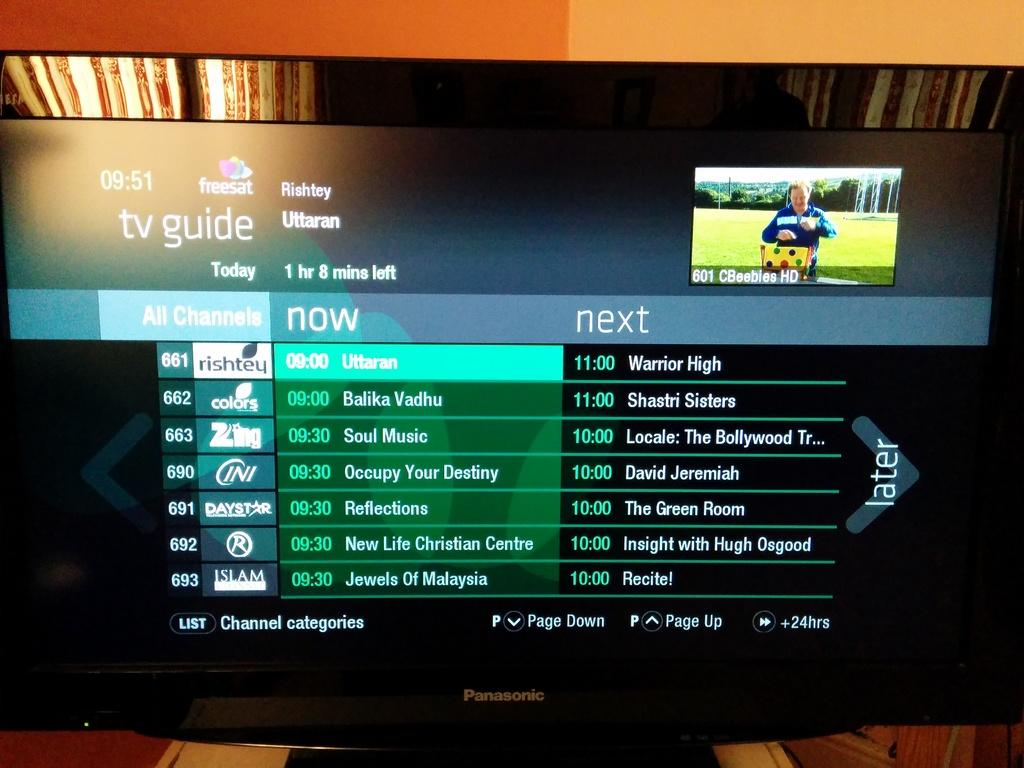<image>
Relay a brief, clear account of the picture shown. Warrior High is coming on next on channel 661. 